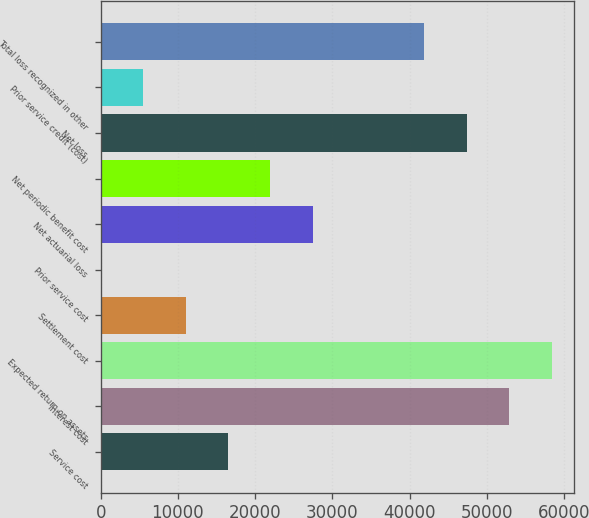Convert chart. <chart><loc_0><loc_0><loc_500><loc_500><bar_chart><fcel>Service cost<fcel>Interest cost<fcel>Expected return on assets<fcel>Settlement cost<fcel>Prior service cost<fcel>Net actuarial loss<fcel>Net periodic benefit cost<fcel>Net loss<fcel>Prior service credit (cost)<fcel>Total loss recognized in other<nl><fcel>16474.8<fcel>52889.2<fcel>58377.8<fcel>10986.2<fcel>9<fcel>27452<fcel>21963.4<fcel>47400.6<fcel>5497.6<fcel>41912<nl></chart> 